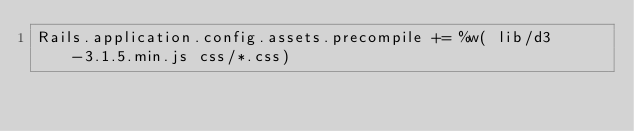Convert code to text. <code><loc_0><loc_0><loc_500><loc_500><_Ruby_>Rails.application.config.assets.precompile += %w( lib/d3-3.1.5.min.js css/*.css)
</code> 